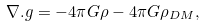Convert formula to latex. <formula><loc_0><loc_0><loc_500><loc_500>\nabla . { g } = - 4 \pi G \rho - 4 \pi G \rho _ { D M } ,</formula> 